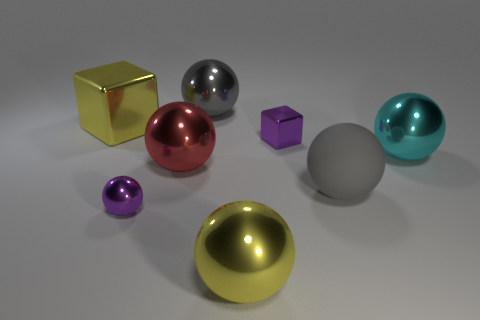Subtract all yellow cubes. How many gray spheres are left? 2 Subtract 2 balls. How many balls are left? 4 Subtract all red spheres. How many spheres are left? 5 Subtract all big gray metal spheres. How many spheres are left? 5 Add 2 yellow things. How many objects exist? 10 Subtract all red balls. Subtract all brown cylinders. How many balls are left? 5 Subtract all balls. How many objects are left? 2 Subtract all purple shiny blocks. Subtract all gray matte spheres. How many objects are left? 6 Add 5 yellow things. How many yellow things are left? 7 Add 2 small metal cubes. How many small metal cubes exist? 3 